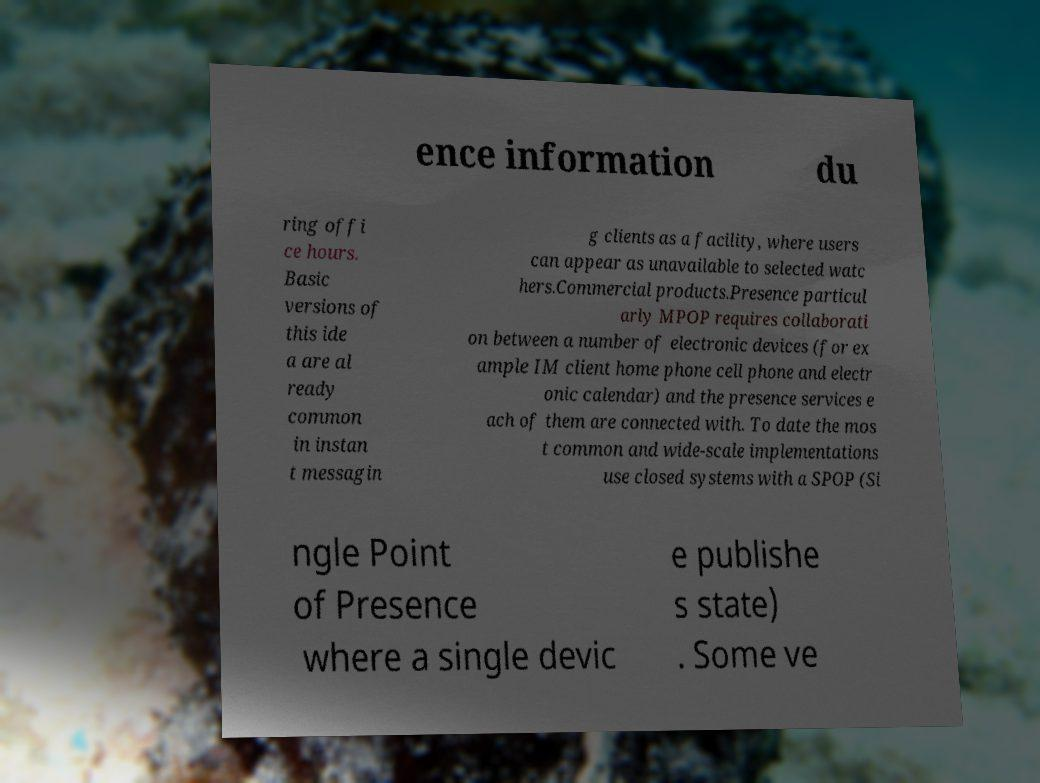What messages or text are displayed in this image? I need them in a readable, typed format. ence information du ring offi ce hours. Basic versions of this ide a are al ready common in instan t messagin g clients as a facility, where users can appear as unavailable to selected watc hers.Commercial products.Presence particul arly MPOP requires collaborati on between a number of electronic devices (for ex ample IM client home phone cell phone and electr onic calendar) and the presence services e ach of them are connected with. To date the mos t common and wide-scale implementations use closed systems with a SPOP (Si ngle Point of Presence where a single devic e publishe s state) . Some ve 